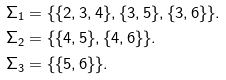<formula> <loc_0><loc_0><loc_500><loc_500>\Sigma _ { 1 } & = \{ \{ 2 , 3 , 4 \} , \{ 3 , 5 \} , \{ 3 , 6 \} \} . \\ \Sigma _ { 2 } & = \{ \{ 4 , 5 \} , \{ 4 , 6 \} \} . \\ \Sigma _ { 3 } & = \{ \{ 5 , 6 \} \} .</formula> 